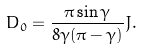Convert formula to latex. <formula><loc_0><loc_0><loc_500><loc_500>D _ { 0 } = \frac { \pi \sin \gamma } { 8 \gamma ( \pi - \gamma ) } J .</formula> 